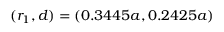Convert formula to latex. <formula><loc_0><loc_0><loc_500><loc_500>( r _ { 1 } , d ) = ( 0 . 3 4 4 5 a , 0 . 2 4 2 5 a )</formula> 